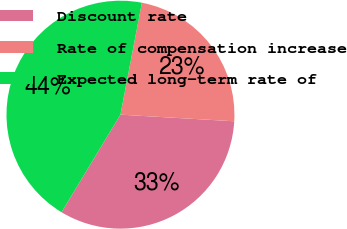Convert chart. <chart><loc_0><loc_0><loc_500><loc_500><pie_chart><fcel>Discount rate<fcel>Rate of compensation increase<fcel>Expected long-term rate of<nl><fcel>32.72%<fcel>22.91%<fcel>44.37%<nl></chart> 